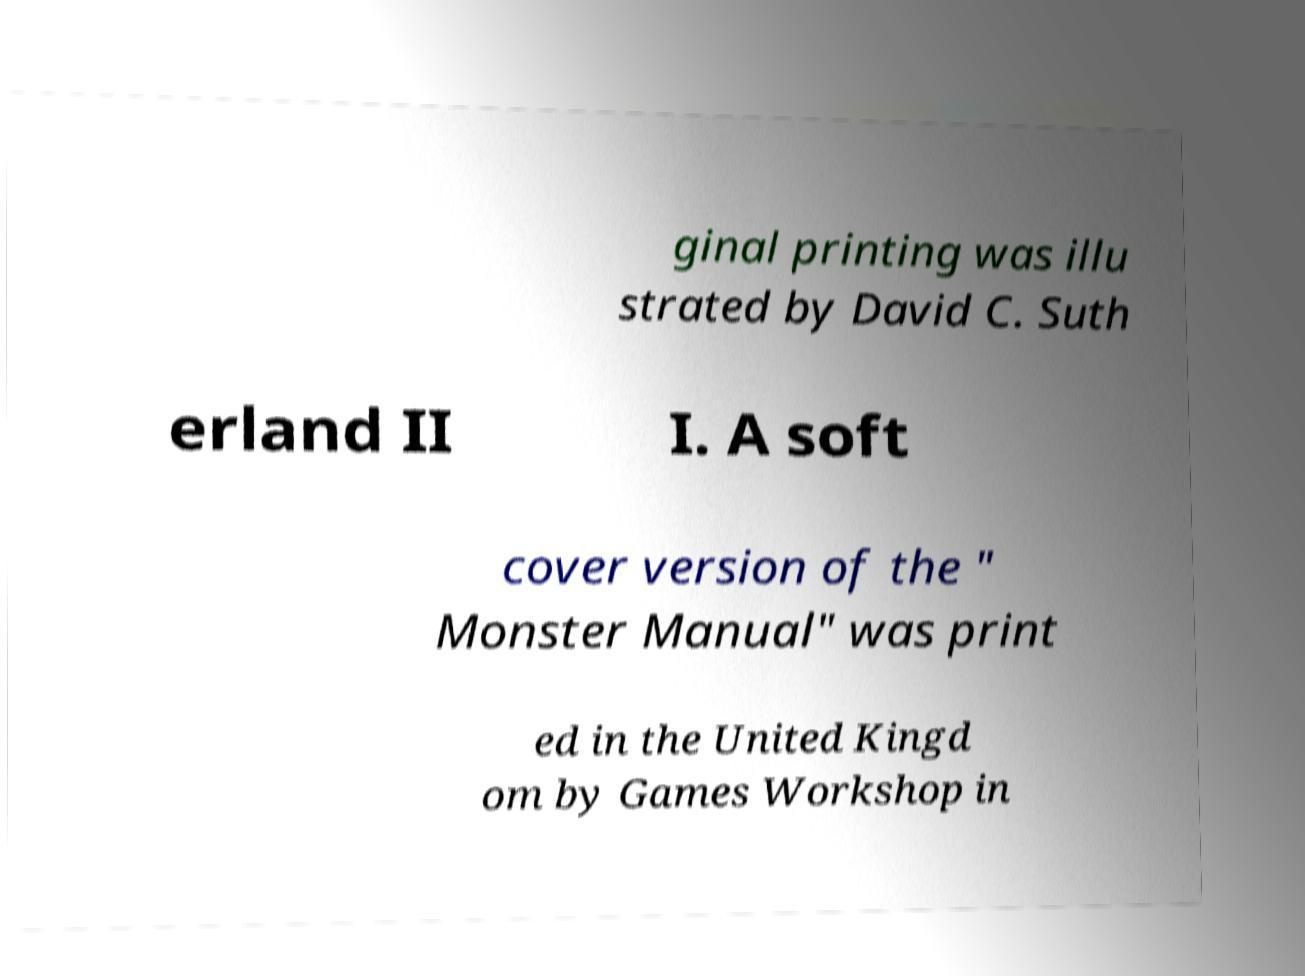I need the written content from this picture converted into text. Can you do that? ginal printing was illu strated by David C. Suth erland II I. A soft cover version of the " Monster Manual" was print ed in the United Kingd om by Games Workshop in 